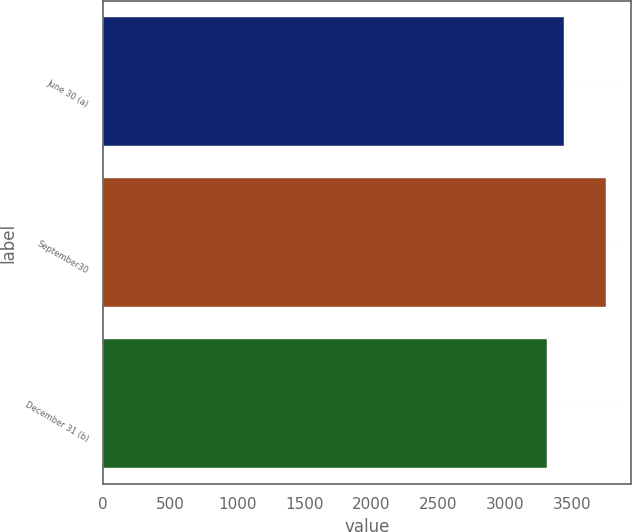<chart> <loc_0><loc_0><loc_500><loc_500><bar_chart><fcel>June 30 (a)<fcel>September30<fcel>December 31 (b)<nl><fcel>3438<fcel>3748<fcel>3312<nl></chart> 